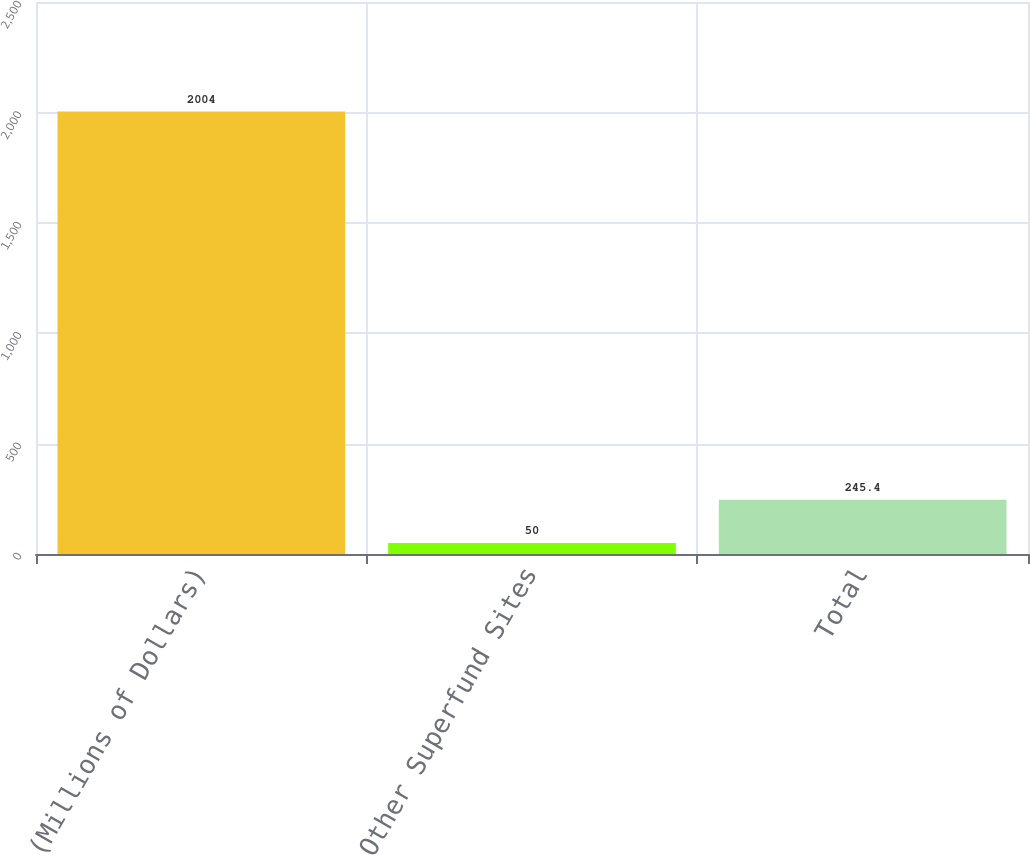Convert chart to OTSL. <chart><loc_0><loc_0><loc_500><loc_500><bar_chart><fcel>(Millions of Dollars)<fcel>Other Superfund Sites<fcel>Total<nl><fcel>2004<fcel>50<fcel>245.4<nl></chart> 